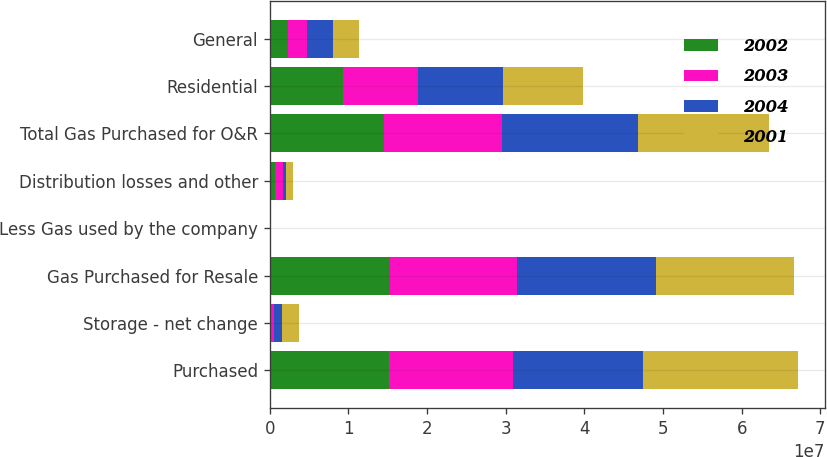Convert chart. <chart><loc_0><loc_0><loc_500><loc_500><stacked_bar_chart><ecel><fcel>Purchased<fcel>Storage - net change<fcel>Gas Purchased for Resale<fcel>Less Gas used by the company<fcel>Distribution losses and other<fcel>Total Gas Purchased for O&R<fcel>Residential<fcel>General<nl><fcel>2002<fcel>1.52083e+07<fcel>121547<fcel>1.53298e+07<fcel>48410<fcel>727243<fcel>1.45542e+07<fcel>9.30659e+06<fcel>2.26921e+06<nl><fcel>2003<fcel>1.57323e+07<fcel>373271<fcel>1.61056e+07<fcel>58823<fcel>1.01713e+06<fcel>1.50296e+07<fcel>9.48676e+06<fcel>2.4872e+06<nl><fcel>2004<fcel>1.65466e+07<fcel>1.11201e+06<fcel>1.76586e+07<fcel>52377<fcel>376605<fcel>1.72296e+07<fcel>1.08104e+07<fcel>3.31415e+06<nl><fcel>2001<fcel>1.97239e+07<fcel>2.13904e+06<fcel>1.75849e+07<fcel>56939<fcel>856036<fcel>1.66719e+07<fcel>1.02034e+07<fcel>3.29462e+06<nl></chart> 